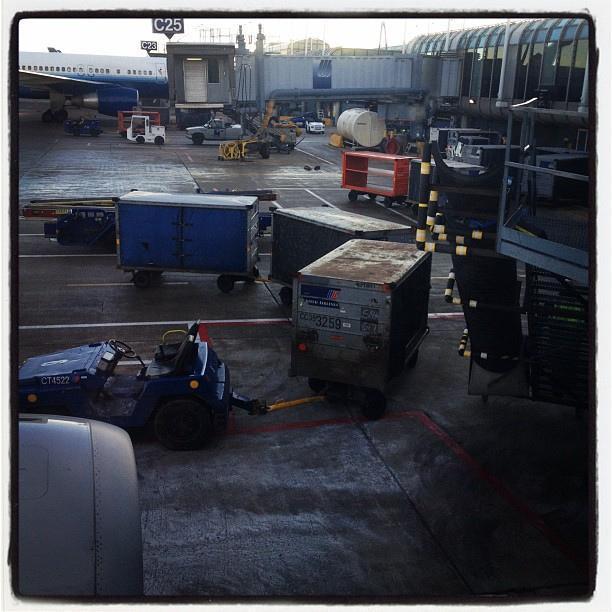What is the blue vehicle doing?
Choose the correct response, then elucidate: 'Answer: answer
Rationale: rationale.'
Options: Pulling, overturning, sinking, burning. Answer: pulling.
Rationale: It has luggage carts hooked to the back 